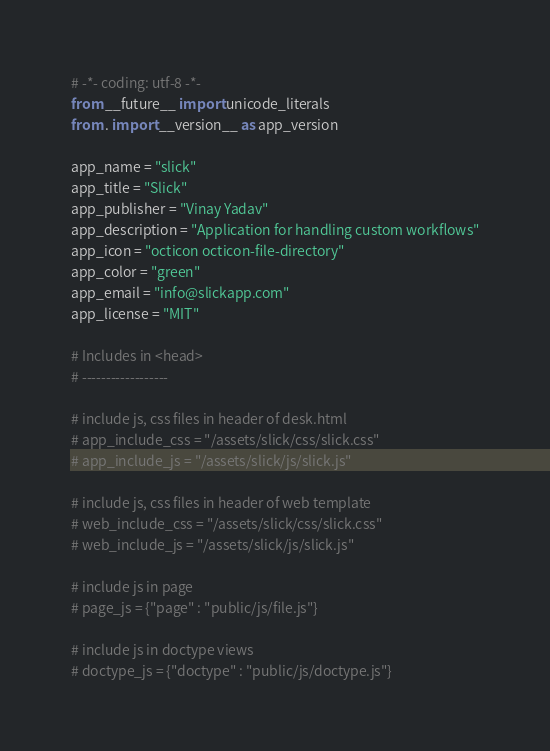<code> <loc_0><loc_0><loc_500><loc_500><_Python_># -*- coding: utf-8 -*-
from __future__ import unicode_literals
from . import __version__ as app_version

app_name = "slick"
app_title = "Slick"
app_publisher = "Vinay Yadav"
app_description = "Application for handling custom workflows"
app_icon = "octicon octicon-file-directory"
app_color = "green"
app_email = "info@slickapp.com"
app_license = "MIT"

# Includes in <head>
# ------------------

# include js, css files in header of desk.html
# app_include_css = "/assets/slick/css/slick.css"
# app_include_js = "/assets/slick/js/slick.js"

# include js, css files in header of web template
# web_include_css = "/assets/slick/css/slick.css"
# web_include_js = "/assets/slick/js/slick.js"

# include js in page
# page_js = {"page" : "public/js/file.js"}

# include js in doctype views
# doctype_js = {"doctype" : "public/js/doctype.js"}</code> 